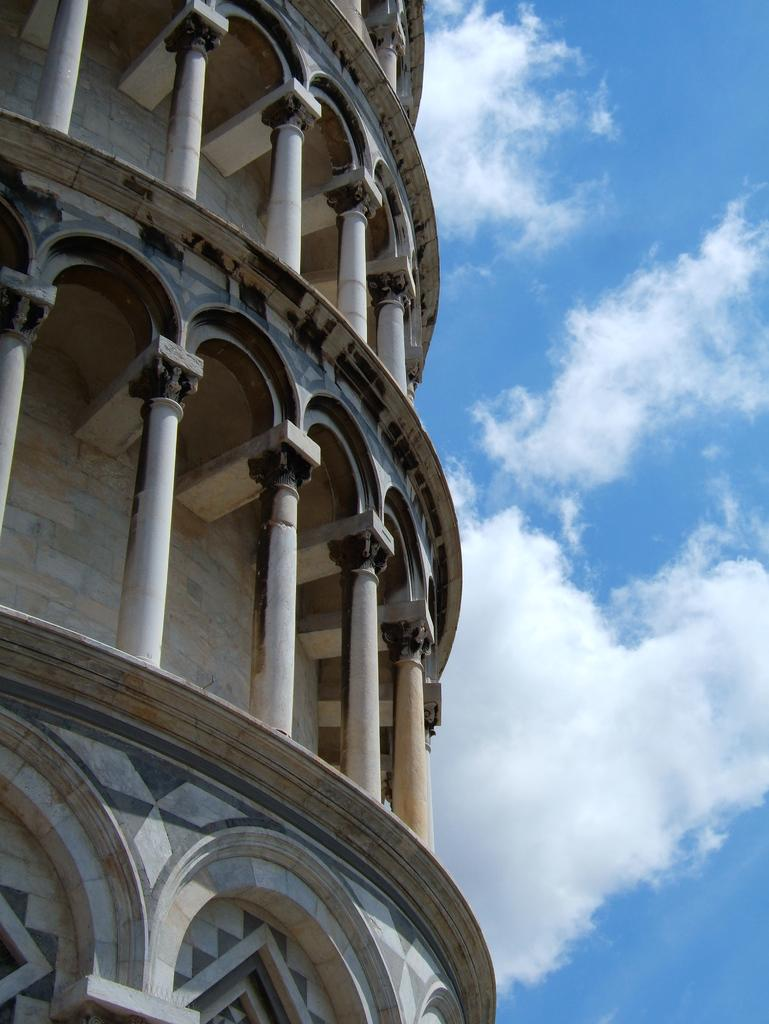What type of structure is present in the image? There is a building in the image. What architectural feature can be seen on the building? The building has pillars. What is visible in the background of the image? The sky is visible in the image. How would you describe the weather based on the sky in the image? The sky appears to be cloudy in the image. What type of underwear is hanging on the building in the image? There is no underwear present in the image; it only features a building with pillars and a cloudy sky. 